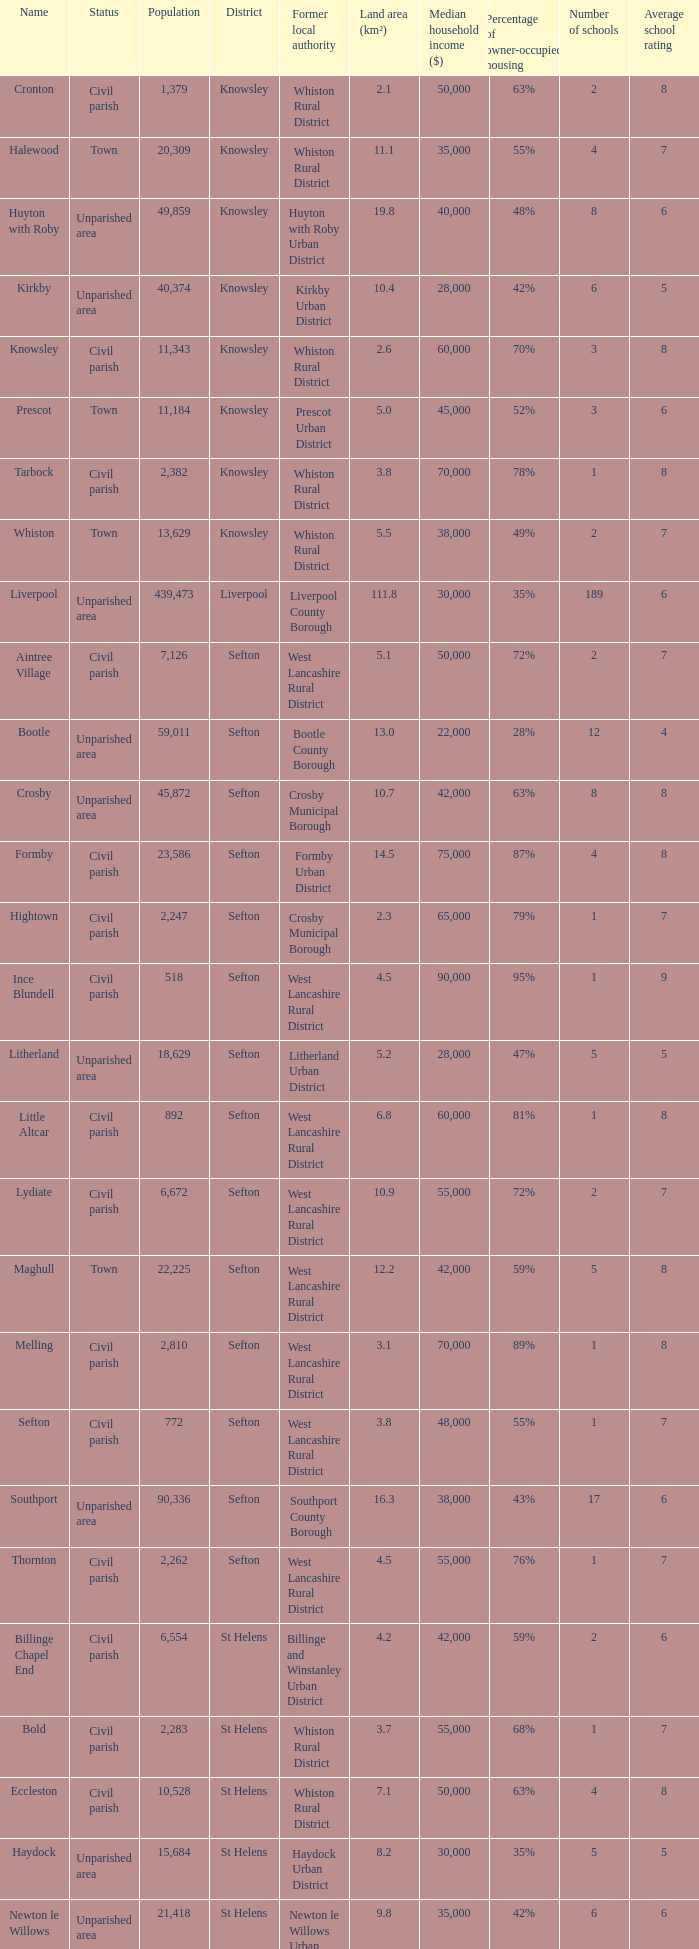What is the district of wallasey Wirral. 